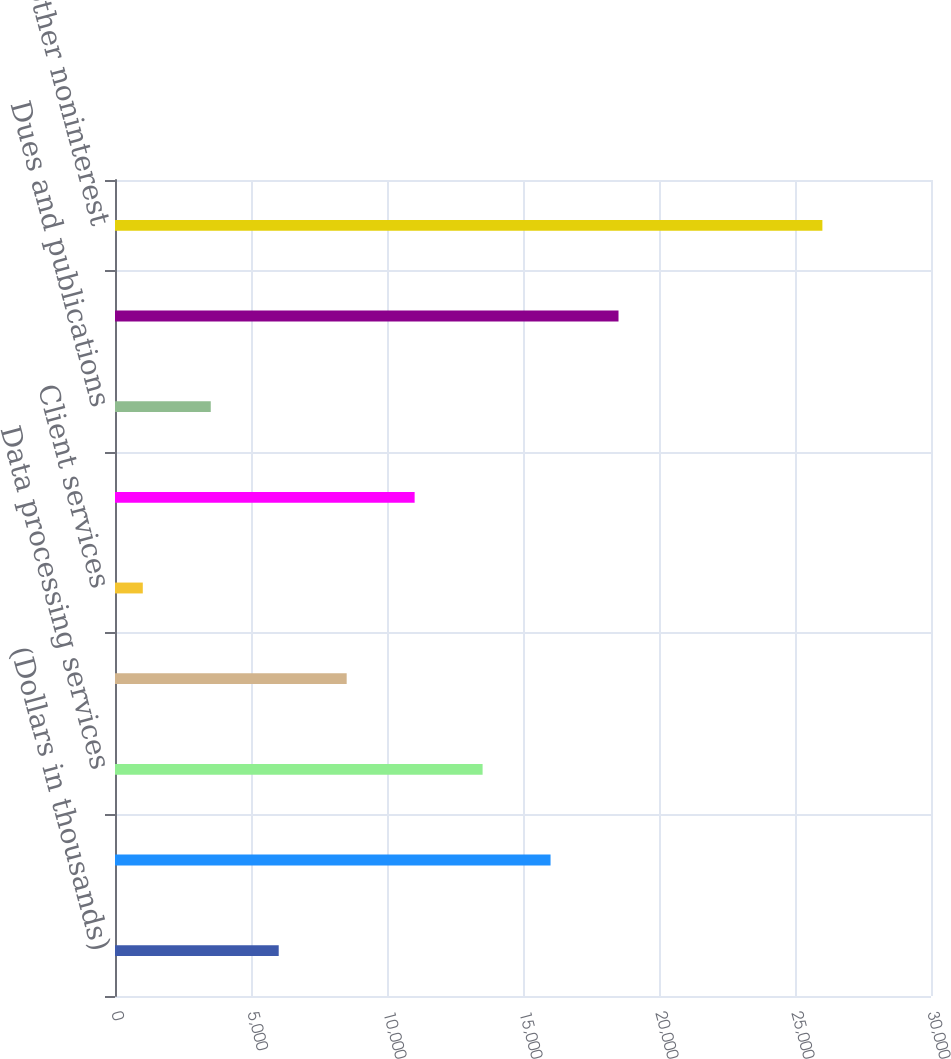Convert chart to OTSL. <chart><loc_0><loc_0><loc_500><loc_500><bar_chart><fcel>(Dollars in thousands)<fcel>Telephone<fcel>Data processing services<fcel>Tax credit fund amortization<fcel>Client services<fcel>Postage and supplies<fcel>Dues and publications<fcel>Other<fcel>Total other noninterest<nl><fcel>6019<fcel>16013<fcel>13514.5<fcel>8517.5<fcel>1022<fcel>11016<fcel>3520.5<fcel>18511.5<fcel>26007<nl></chart> 